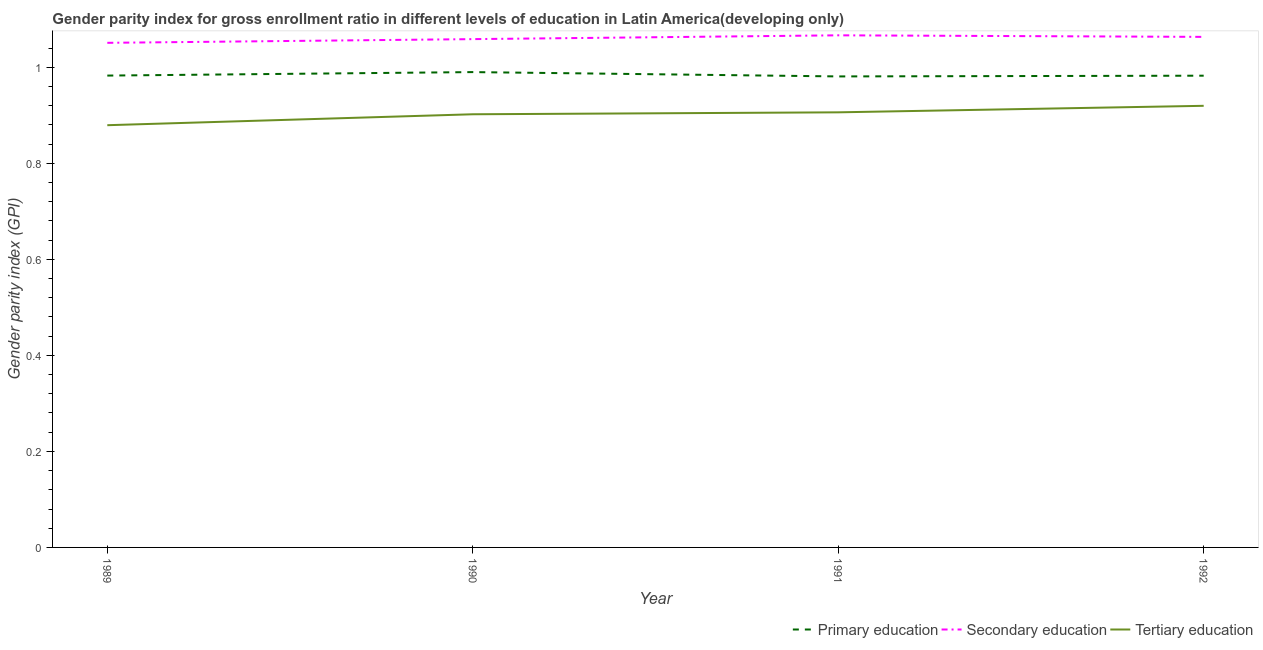Does the line corresponding to gender parity index in tertiary education intersect with the line corresponding to gender parity index in secondary education?
Your answer should be very brief. No. Is the number of lines equal to the number of legend labels?
Provide a short and direct response. Yes. What is the gender parity index in primary education in 1991?
Provide a short and direct response. 0.98. Across all years, what is the maximum gender parity index in secondary education?
Offer a terse response. 1.07. Across all years, what is the minimum gender parity index in primary education?
Ensure brevity in your answer.  0.98. What is the total gender parity index in primary education in the graph?
Provide a succinct answer. 3.94. What is the difference between the gender parity index in tertiary education in 1989 and that in 1990?
Offer a terse response. -0.02. What is the difference between the gender parity index in secondary education in 1990 and the gender parity index in tertiary education in 1989?
Your answer should be compact. 0.18. What is the average gender parity index in secondary education per year?
Your answer should be very brief. 1.06. In the year 1989, what is the difference between the gender parity index in primary education and gender parity index in tertiary education?
Ensure brevity in your answer.  0.1. What is the ratio of the gender parity index in primary education in 1989 to that in 1991?
Your response must be concise. 1. Is the gender parity index in primary education in 1990 less than that in 1991?
Your response must be concise. No. What is the difference between the highest and the second highest gender parity index in secondary education?
Make the answer very short. 0. What is the difference between the highest and the lowest gender parity index in secondary education?
Offer a terse response. 0.02. In how many years, is the gender parity index in tertiary education greater than the average gender parity index in tertiary education taken over all years?
Keep it short and to the point. 3. Is the sum of the gender parity index in primary education in 1991 and 1992 greater than the maximum gender parity index in tertiary education across all years?
Make the answer very short. Yes. Is it the case that in every year, the sum of the gender parity index in primary education and gender parity index in secondary education is greater than the gender parity index in tertiary education?
Keep it short and to the point. Yes. Does the gender parity index in primary education monotonically increase over the years?
Provide a short and direct response. No. Is the gender parity index in tertiary education strictly less than the gender parity index in secondary education over the years?
Make the answer very short. Yes. How many lines are there?
Your answer should be very brief. 3. How many years are there in the graph?
Offer a very short reply. 4. Are the values on the major ticks of Y-axis written in scientific E-notation?
Your answer should be compact. No. Does the graph contain any zero values?
Provide a succinct answer. No. Does the graph contain grids?
Provide a short and direct response. No. Where does the legend appear in the graph?
Provide a short and direct response. Bottom right. How are the legend labels stacked?
Your answer should be compact. Horizontal. What is the title of the graph?
Your response must be concise. Gender parity index for gross enrollment ratio in different levels of education in Latin America(developing only). What is the label or title of the Y-axis?
Provide a succinct answer. Gender parity index (GPI). What is the Gender parity index (GPI) in Primary education in 1989?
Give a very brief answer. 0.98. What is the Gender parity index (GPI) of Secondary education in 1989?
Provide a succinct answer. 1.05. What is the Gender parity index (GPI) of Tertiary education in 1989?
Offer a terse response. 0.88. What is the Gender parity index (GPI) of Primary education in 1990?
Keep it short and to the point. 0.99. What is the Gender parity index (GPI) of Secondary education in 1990?
Your response must be concise. 1.06. What is the Gender parity index (GPI) in Tertiary education in 1990?
Your answer should be very brief. 0.9. What is the Gender parity index (GPI) of Primary education in 1991?
Your answer should be compact. 0.98. What is the Gender parity index (GPI) in Secondary education in 1991?
Keep it short and to the point. 1.07. What is the Gender parity index (GPI) of Tertiary education in 1991?
Offer a very short reply. 0.91. What is the Gender parity index (GPI) in Primary education in 1992?
Offer a very short reply. 0.98. What is the Gender parity index (GPI) in Secondary education in 1992?
Give a very brief answer. 1.06. What is the Gender parity index (GPI) of Tertiary education in 1992?
Your answer should be very brief. 0.92. Across all years, what is the maximum Gender parity index (GPI) in Primary education?
Your answer should be compact. 0.99. Across all years, what is the maximum Gender parity index (GPI) in Secondary education?
Provide a succinct answer. 1.07. Across all years, what is the maximum Gender parity index (GPI) in Tertiary education?
Your response must be concise. 0.92. Across all years, what is the minimum Gender parity index (GPI) of Primary education?
Ensure brevity in your answer.  0.98. Across all years, what is the minimum Gender parity index (GPI) of Secondary education?
Offer a terse response. 1.05. Across all years, what is the minimum Gender parity index (GPI) in Tertiary education?
Your answer should be very brief. 0.88. What is the total Gender parity index (GPI) in Primary education in the graph?
Give a very brief answer. 3.94. What is the total Gender parity index (GPI) of Secondary education in the graph?
Give a very brief answer. 4.24. What is the total Gender parity index (GPI) of Tertiary education in the graph?
Provide a succinct answer. 3.61. What is the difference between the Gender parity index (GPI) of Primary education in 1989 and that in 1990?
Offer a very short reply. -0.01. What is the difference between the Gender parity index (GPI) of Secondary education in 1989 and that in 1990?
Your answer should be very brief. -0.01. What is the difference between the Gender parity index (GPI) of Tertiary education in 1989 and that in 1990?
Your response must be concise. -0.02. What is the difference between the Gender parity index (GPI) of Primary education in 1989 and that in 1991?
Ensure brevity in your answer.  0. What is the difference between the Gender parity index (GPI) of Secondary education in 1989 and that in 1991?
Your response must be concise. -0.02. What is the difference between the Gender parity index (GPI) in Tertiary education in 1989 and that in 1991?
Keep it short and to the point. -0.03. What is the difference between the Gender parity index (GPI) in Secondary education in 1989 and that in 1992?
Your answer should be compact. -0.01. What is the difference between the Gender parity index (GPI) of Tertiary education in 1989 and that in 1992?
Keep it short and to the point. -0.04. What is the difference between the Gender parity index (GPI) of Primary education in 1990 and that in 1991?
Provide a short and direct response. 0.01. What is the difference between the Gender parity index (GPI) of Secondary education in 1990 and that in 1991?
Keep it short and to the point. -0.01. What is the difference between the Gender parity index (GPI) in Tertiary education in 1990 and that in 1991?
Provide a succinct answer. -0. What is the difference between the Gender parity index (GPI) of Primary education in 1990 and that in 1992?
Provide a succinct answer. 0.01. What is the difference between the Gender parity index (GPI) in Secondary education in 1990 and that in 1992?
Your response must be concise. -0. What is the difference between the Gender parity index (GPI) in Tertiary education in 1990 and that in 1992?
Provide a succinct answer. -0.02. What is the difference between the Gender parity index (GPI) of Primary education in 1991 and that in 1992?
Your answer should be very brief. -0. What is the difference between the Gender parity index (GPI) of Secondary education in 1991 and that in 1992?
Your answer should be very brief. 0. What is the difference between the Gender parity index (GPI) of Tertiary education in 1991 and that in 1992?
Your response must be concise. -0.01. What is the difference between the Gender parity index (GPI) of Primary education in 1989 and the Gender parity index (GPI) of Secondary education in 1990?
Your answer should be compact. -0.08. What is the difference between the Gender parity index (GPI) in Primary education in 1989 and the Gender parity index (GPI) in Tertiary education in 1990?
Make the answer very short. 0.08. What is the difference between the Gender parity index (GPI) in Secondary education in 1989 and the Gender parity index (GPI) in Tertiary education in 1990?
Offer a terse response. 0.15. What is the difference between the Gender parity index (GPI) of Primary education in 1989 and the Gender parity index (GPI) of Secondary education in 1991?
Offer a terse response. -0.08. What is the difference between the Gender parity index (GPI) of Primary education in 1989 and the Gender parity index (GPI) of Tertiary education in 1991?
Your response must be concise. 0.08. What is the difference between the Gender parity index (GPI) in Secondary education in 1989 and the Gender parity index (GPI) in Tertiary education in 1991?
Provide a short and direct response. 0.14. What is the difference between the Gender parity index (GPI) of Primary education in 1989 and the Gender parity index (GPI) of Secondary education in 1992?
Offer a terse response. -0.08. What is the difference between the Gender parity index (GPI) in Primary education in 1989 and the Gender parity index (GPI) in Tertiary education in 1992?
Provide a succinct answer. 0.06. What is the difference between the Gender parity index (GPI) in Secondary education in 1989 and the Gender parity index (GPI) in Tertiary education in 1992?
Your response must be concise. 0.13. What is the difference between the Gender parity index (GPI) in Primary education in 1990 and the Gender parity index (GPI) in Secondary education in 1991?
Provide a succinct answer. -0.08. What is the difference between the Gender parity index (GPI) in Primary education in 1990 and the Gender parity index (GPI) in Tertiary education in 1991?
Provide a short and direct response. 0.08. What is the difference between the Gender parity index (GPI) of Secondary education in 1990 and the Gender parity index (GPI) of Tertiary education in 1991?
Make the answer very short. 0.15. What is the difference between the Gender parity index (GPI) in Primary education in 1990 and the Gender parity index (GPI) in Secondary education in 1992?
Offer a very short reply. -0.07. What is the difference between the Gender parity index (GPI) of Primary education in 1990 and the Gender parity index (GPI) of Tertiary education in 1992?
Provide a succinct answer. 0.07. What is the difference between the Gender parity index (GPI) of Secondary education in 1990 and the Gender parity index (GPI) of Tertiary education in 1992?
Offer a very short reply. 0.14. What is the difference between the Gender parity index (GPI) in Primary education in 1991 and the Gender parity index (GPI) in Secondary education in 1992?
Keep it short and to the point. -0.08. What is the difference between the Gender parity index (GPI) of Primary education in 1991 and the Gender parity index (GPI) of Tertiary education in 1992?
Your response must be concise. 0.06. What is the difference between the Gender parity index (GPI) in Secondary education in 1991 and the Gender parity index (GPI) in Tertiary education in 1992?
Provide a short and direct response. 0.15. What is the average Gender parity index (GPI) of Secondary education per year?
Offer a terse response. 1.06. What is the average Gender parity index (GPI) of Tertiary education per year?
Make the answer very short. 0.9. In the year 1989, what is the difference between the Gender parity index (GPI) in Primary education and Gender parity index (GPI) in Secondary education?
Give a very brief answer. -0.07. In the year 1989, what is the difference between the Gender parity index (GPI) in Primary education and Gender parity index (GPI) in Tertiary education?
Your answer should be compact. 0.1. In the year 1989, what is the difference between the Gender parity index (GPI) in Secondary education and Gender parity index (GPI) in Tertiary education?
Offer a very short reply. 0.17. In the year 1990, what is the difference between the Gender parity index (GPI) in Primary education and Gender parity index (GPI) in Secondary education?
Ensure brevity in your answer.  -0.07. In the year 1990, what is the difference between the Gender parity index (GPI) of Primary education and Gender parity index (GPI) of Tertiary education?
Offer a terse response. 0.09. In the year 1990, what is the difference between the Gender parity index (GPI) of Secondary education and Gender parity index (GPI) of Tertiary education?
Your response must be concise. 0.16. In the year 1991, what is the difference between the Gender parity index (GPI) of Primary education and Gender parity index (GPI) of Secondary education?
Provide a short and direct response. -0.09. In the year 1991, what is the difference between the Gender parity index (GPI) in Primary education and Gender parity index (GPI) in Tertiary education?
Provide a succinct answer. 0.07. In the year 1991, what is the difference between the Gender parity index (GPI) of Secondary education and Gender parity index (GPI) of Tertiary education?
Your response must be concise. 0.16. In the year 1992, what is the difference between the Gender parity index (GPI) of Primary education and Gender parity index (GPI) of Secondary education?
Provide a succinct answer. -0.08. In the year 1992, what is the difference between the Gender parity index (GPI) in Primary education and Gender parity index (GPI) in Tertiary education?
Provide a short and direct response. 0.06. In the year 1992, what is the difference between the Gender parity index (GPI) of Secondary education and Gender parity index (GPI) of Tertiary education?
Your response must be concise. 0.14. What is the ratio of the Gender parity index (GPI) of Secondary education in 1989 to that in 1990?
Give a very brief answer. 0.99. What is the ratio of the Gender parity index (GPI) of Tertiary education in 1989 to that in 1990?
Provide a succinct answer. 0.97. What is the ratio of the Gender parity index (GPI) of Primary education in 1989 to that in 1991?
Give a very brief answer. 1. What is the ratio of the Gender parity index (GPI) in Tertiary education in 1989 to that in 1991?
Make the answer very short. 0.97. What is the ratio of the Gender parity index (GPI) in Primary education in 1989 to that in 1992?
Offer a terse response. 1. What is the ratio of the Gender parity index (GPI) of Secondary education in 1989 to that in 1992?
Your response must be concise. 0.99. What is the ratio of the Gender parity index (GPI) of Tertiary education in 1989 to that in 1992?
Make the answer very short. 0.96. What is the ratio of the Gender parity index (GPI) in Primary education in 1990 to that in 1991?
Give a very brief answer. 1.01. What is the ratio of the Gender parity index (GPI) of Secondary education in 1990 to that in 1991?
Offer a terse response. 0.99. What is the ratio of the Gender parity index (GPI) of Tertiary education in 1990 to that in 1991?
Provide a succinct answer. 1. What is the ratio of the Gender parity index (GPI) of Primary education in 1990 to that in 1992?
Provide a short and direct response. 1.01. What is the ratio of the Gender parity index (GPI) of Secondary education in 1990 to that in 1992?
Ensure brevity in your answer.  1. What is the ratio of the Gender parity index (GPI) in Tertiary education in 1990 to that in 1992?
Keep it short and to the point. 0.98. What is the ratio of the Gender parity index (GPI) in Secondary education in 1991 to that in 1992?
Provide a succinct answer. 1. What is the ratio of the Gender parity index (GPI) in Tertiary education in 1991 to that in 1992?
Make the answer very short. 0.99. What is the difference between the highest and the second highest Gender parity index (GPI) in Primary education?
Make the answer very short. 0.01. What is the difference between the highest and the second highest Gender parity index (GPI) in Secondary education?
Provide a succinct answer. 0. What is the difference between the highest and the second highest Gender parity index (GPI) in Tertiary education?
Provide a short and direct response. 0.01. What is the difference between the highest and the lowest Gender parity index (GPI) in Primary education?
Your answer should be compact. 0.01. What is the difference between the highest and the lowest Gender parity index (GPI) in Secondary education?
Provide a short and direct response. 0.02. What is the difference between the highest and the lowest Gender parity index (GPI) of Tertiary education?
Keep it short and to the point. 0.04. 